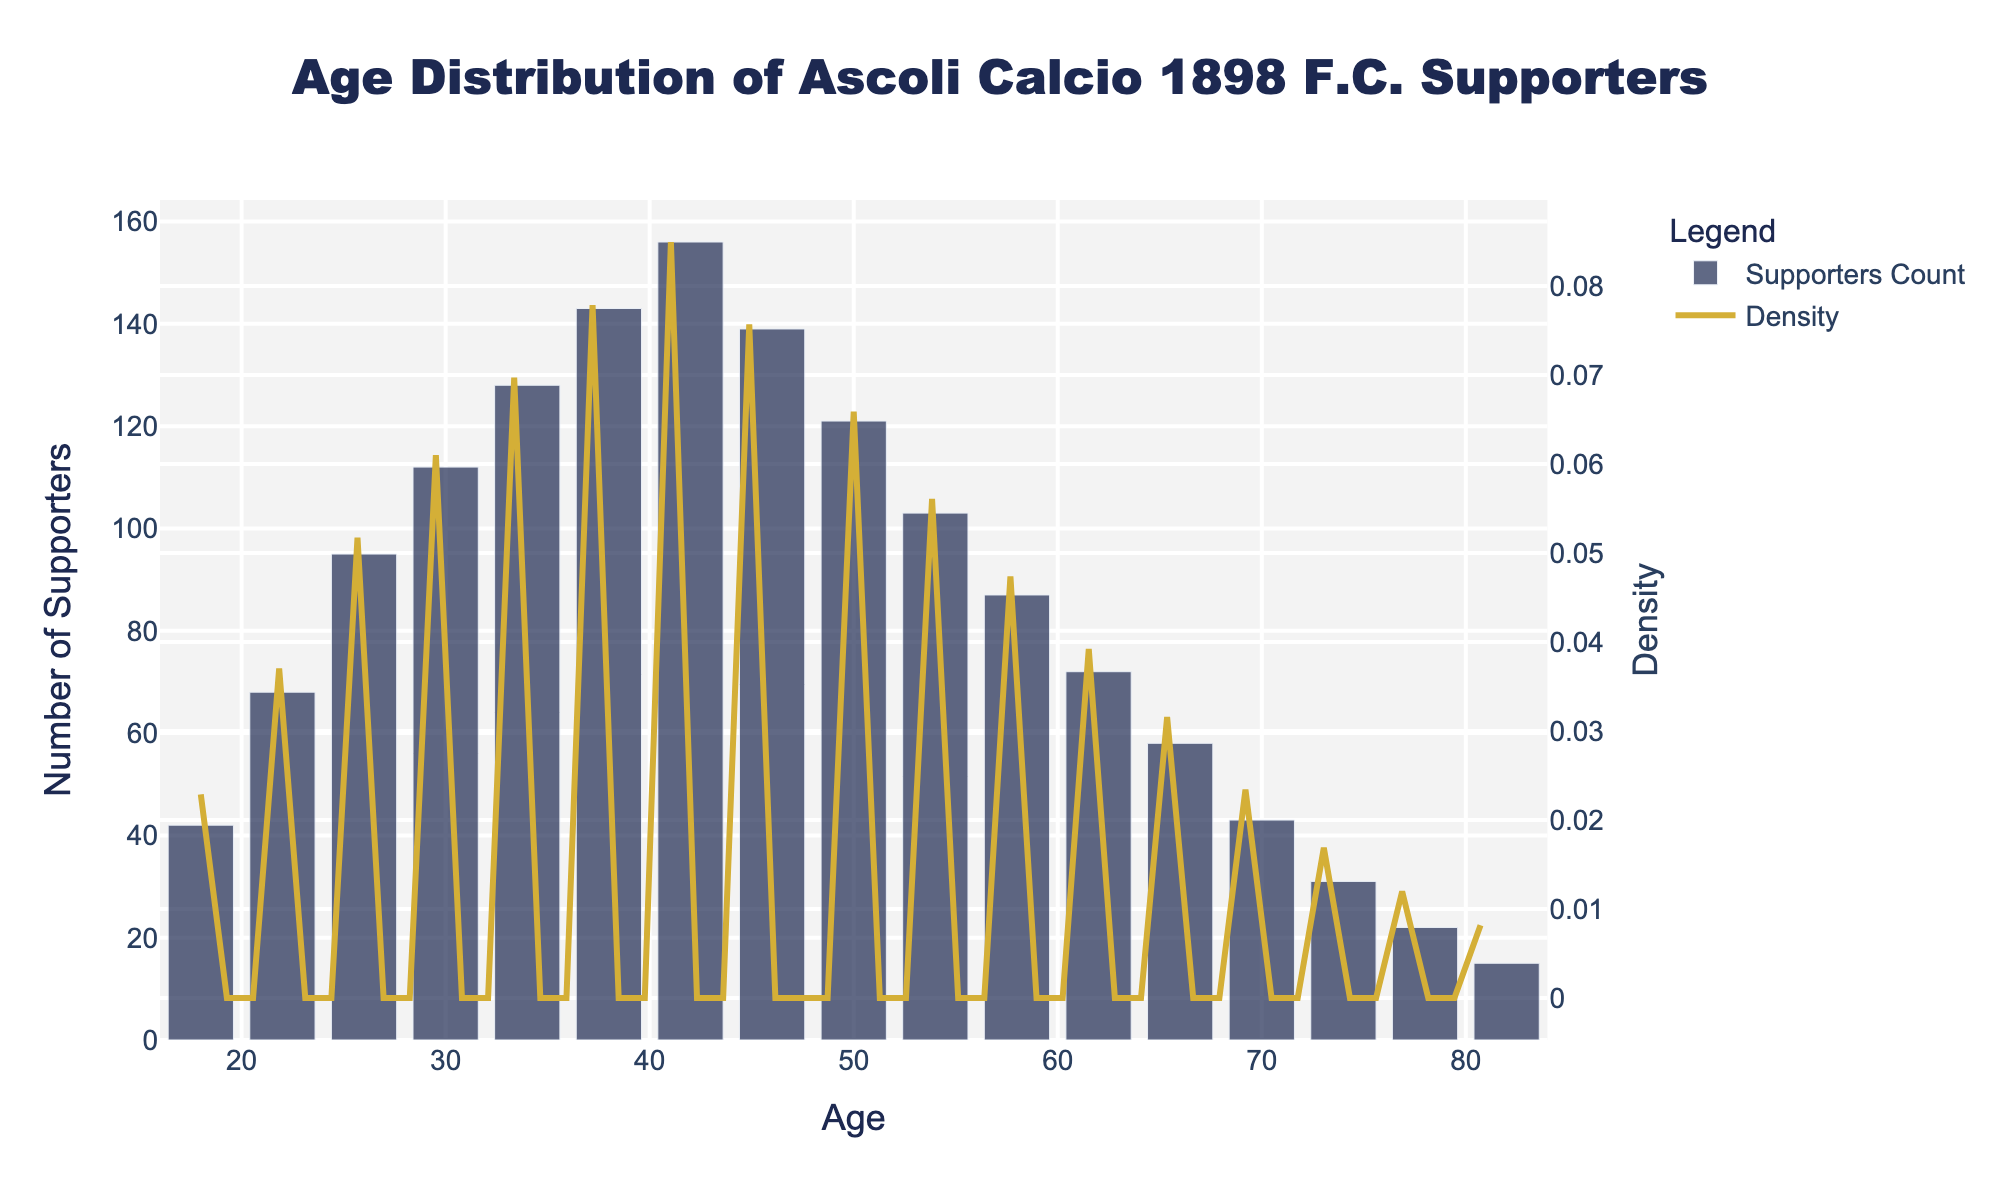What is the age range of Ascoli Calcio supporters attending home matches? To find the age range, look at the lowest and highest ages on the x-axis. The lowest age is 18, and the highest age is 82.
Answer: 18 to 82 Which age group has the highest number of supporters? Identify the tallest bar in the histogram. The 42 age group has the highest bar.
Answer: 42 How many supporters are in the 58 age group? Locate the bar corresponding to age 58 on the x-axis and read its height on the y-axis. The bar for age 58 corresponds to 87 supporters.
Answer: 87 Which age group has a higher number of supporters: 34 or 54? Compare the heights of the bars for ages 34 and 54. The height for age 34 is 128, while for age 54 it is 103. Therefore, the 34 age group has more supporters.
Answer: 34 What is the trend of the density curve as age increases beyond 42? Look at the KDE curve shape after age 42. The density curve decreases as age increases beyond 42.
Answer: Decreases What is the average number of supporters in the 30, 34, and 38 age groups? Add the number of supporters in age groups 30 (112), 34 (128), and 38 (143), then divide by 3 to find the average. (112 + 128 + 143) / 3 = 127.67
Answer: 127.67 Which age group has a sharper decline in the number of supporters: from 66 to 70 or from 70 to 74? Compare the differences in the heights of bars from 66 to 70 (58 to 43) and from 70 to 74 (43 to 31). The decline from 66 to 70 is 15, while from 70 to 74 is 12. Therefore, the decline from 66 to 70 is sharper.
Answer: 66 to 70 What does the KDE curve help to understand beyond the histogram? The KDE curve smooths the data and shows the probability density of the age distribution, helping to visualize the overall trend and identify age clusters more clearly than individual bars alone.
Answer: Shows probability density and trend How might the density curve be interpreted for understanding supporter distribution? The density curve indicates areas of higher supporter concentration by showing peaks, and its shape helps identify age groups where supporters are more frequently found.
Answer: Area concentration and peaks 